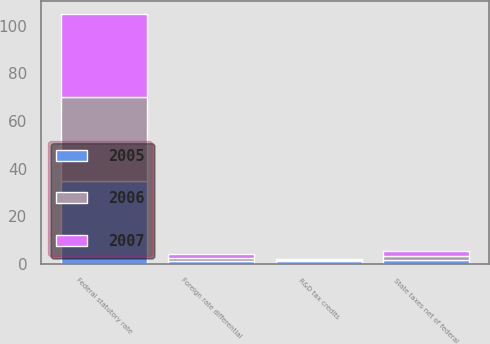<chart> <loc_0><loc_0><loc_500><loc_500><stacked_bar_chart><ecel><fcel>Federal statutory rate<fcel>Foreign rate differential<fcel>R&D tax credits<fcel>State taxes net of federal<nl><fcel>2007<fcel>35<fcel>1.66<fcel>0.44<fcel>1.93<nl><fcel>2006<fcel>35<fcel>0.97<fcel>0.36<fcel>1.67<nl><fcel>2005<fcel>35<fcel>1.33<fcel>1.2<fcel>1.79<nl></chart> 